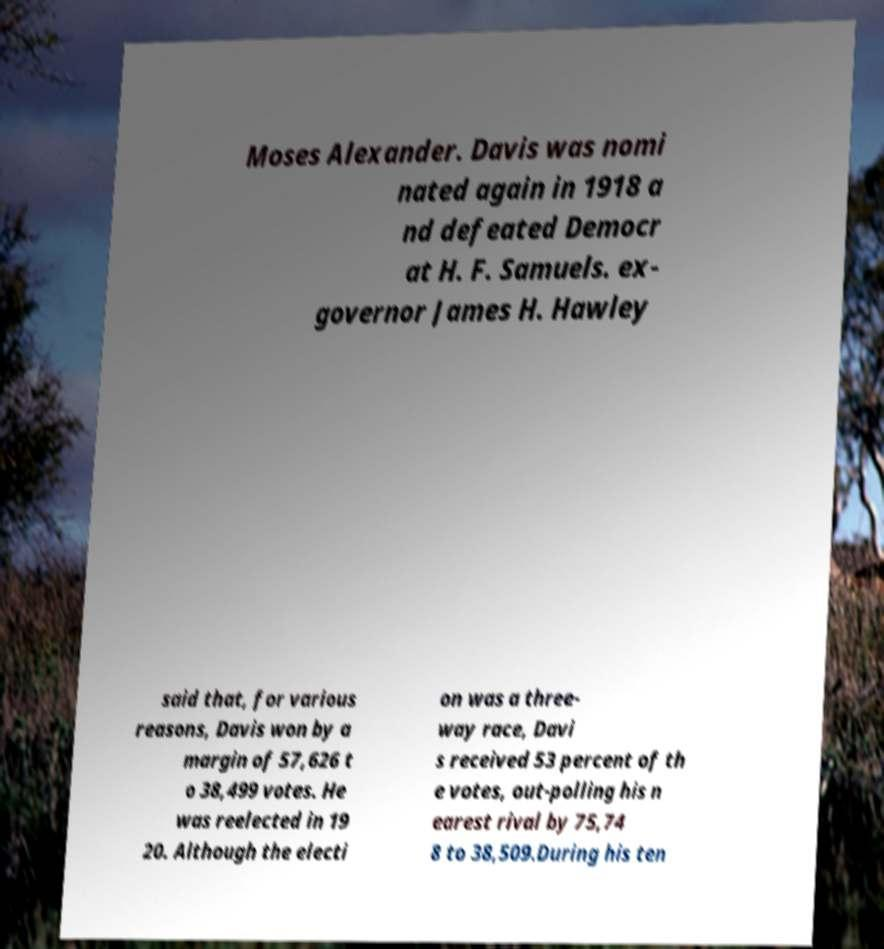There's text embedded in this image that I need extracted. Can you transcribe it verbatim? Moses Alexander. Davis was nomi nated again in 1918 a nd defeated Democr at H. F. Samuels. ex- governor James H. Hawley said that, for various reasons, Davis won by a margin of 57,626 t o 38,499 votes. He was reelected in 19 20. Although the electi on was a three- way race, Davi s received 53 percent of th e votes, out-polling his n earest rival by 75,74 8 to 38,509.During his ten 